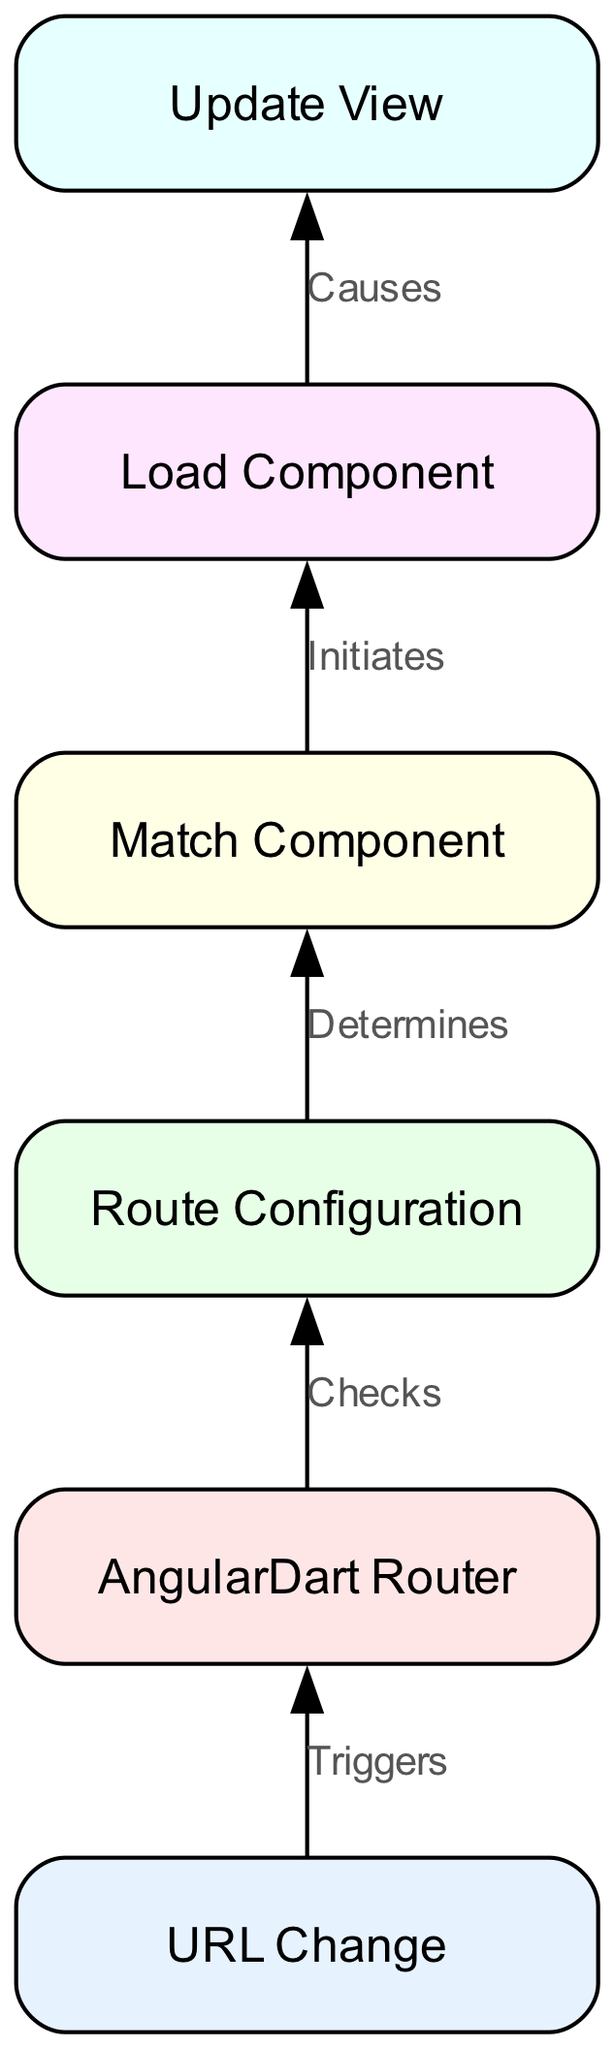What is the first node in the diagram? The diagram starts with the node labeled "URL Change," which signifies the initial trigger for routing in AngularDart.
Answer: URL Change How many nodes are present in the diagram? By counting the nodes listed, we find there are six distinct nodes representing different stages of the routing process.
Answer: 6 What does the "AngularDart Router" node do? The "AngularDart Router" node checks the route configurations based on the incoming URL change to determine how to handle the navigation.
Answer: Checks What action does the "component_match" node perform? The "component_match" node is responsible for determining which component should be matched to the specified route that corresponds to the URL change.
Answer: Determines Which nodes are directly linked to the "component_load" node? The "component_load" node is directly connected to the "component_match" node, indicating that it initiates the loading of the matched component.
Answer: component_match What is the final step in the routing process depicted in the diagram? The last step illustrated in the diagram is the "Update View," which indicates that the view is refreshed to display the newly loaded component after the routing process.
Answer: Update View What triggers the routing process in this diagram? The entire routing process is initiated by a change in the URL, which serves as the starting point for the routing navigation in AngularDart.
Answer: URL Change What is the relationship between the "component_load" and "view_update" nodes? The relationship shows that the process of loading a component (component_load) directly causes the view to be updated (view_update), indicating a sequential action.
Answer: Causes What component is indicated to be initiated by the "component_match"? The "component_match" node initiates the loading of the specific component that matches the determined route configuration for the URL change.
Answer: Load Component 